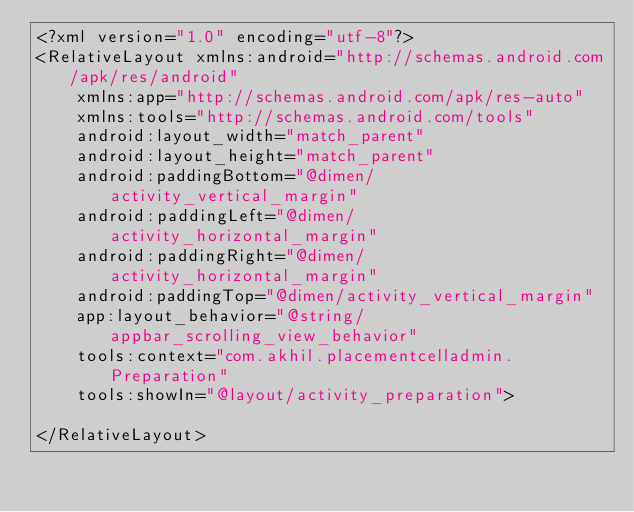<code> <loc_0><loc_0><loc_500><loc_500><_XML_><?xml version="1.0" encoding="utf-8"?>
<RelativeLayout xmlns:android="http://schemas.android.com/apk/res/android"
    xmlns:app="http://schemas.android.com/apk/res-auto"
    xmlns:tools="http://schemas.android.com/tools"
    android:layout_width="match_parent"
    android:layout_height="match_parent"
    android:paddingBottom="@dimen/activity_vertical_margin"
    android:paddingLeft="@dimen/activity_horizontal_margin"
    android:paddingRight="@dimen/activity_horizontal_margin"
    android:paddingTop="@dimen/activity_vertical_margin"
    app:layout_behavior="@string/appbar_scrolling_view_behavior"
    tools:context="com.akhil.placementcelladmin.Preparation"
    tools:showIn="@layout/activity_preparation">

</RelativeLayout>
</code> 